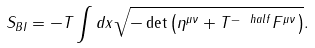<formula> <loc_0><loc_0><loc_500><loc_500>S _ { B I } = - T \int d x \sqrt { - \det \left ( \eta ^ { \mu \nu } + T ^ { - \ h a l f } F ^ { \mu \nu } \right ) } .</formula> 